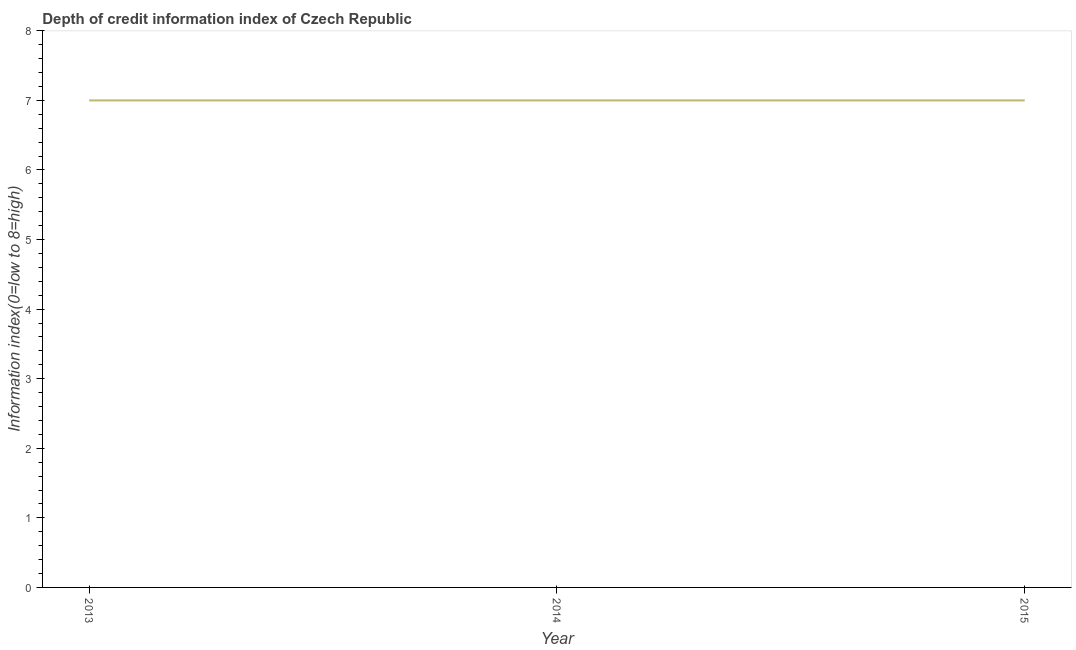What is the depth of credit information index in 2013?
Give a very brief answer. 7. Across all years, what is the maximum depth of credit information index?
Offer a terse response. 7. Across all years, what is the minimum depth of credit information index?
Your response must be concise. 7. What is the sum of the depth of credit information index?
Offer a very short reply. 21. Is the difference between the depth of credit information index in 2013 and 2015 greater than the difference between any two years?
Ensure brevity in your answer.  Yes. How many lines are there?
Your answer should be compact. 1. What is the difference between two consecutive major ticks on the Y-axis?
Provide a succinct answer. 1. Does the graph contain any zero values?
Provide a succinct answer. No. What is the title of the graph?
Offer a terse response. Depth of credit information index of Czech Republic. What is the label or title of the X-axis?
Your answer should be very brief. Year. What is the label or title of the Y-axis?
Offer a terse response. Information index(0=low to 8=high). What is the Information index(0=low to 8=high) of 2013?
Offer a terse response. 7. What is the difference between the Information index(0=low to 8=high) in 2013 and 2015?
Offer a terse response. 0. What is the difference between the Information index(0=low to 8=high) in 2014 and 2015?
Ensure brevity in your answer.  0. What is the ratio of the Information index(0=low to 8=high) in 2013 to that in 2014?
Your answer should be compact. 1. 